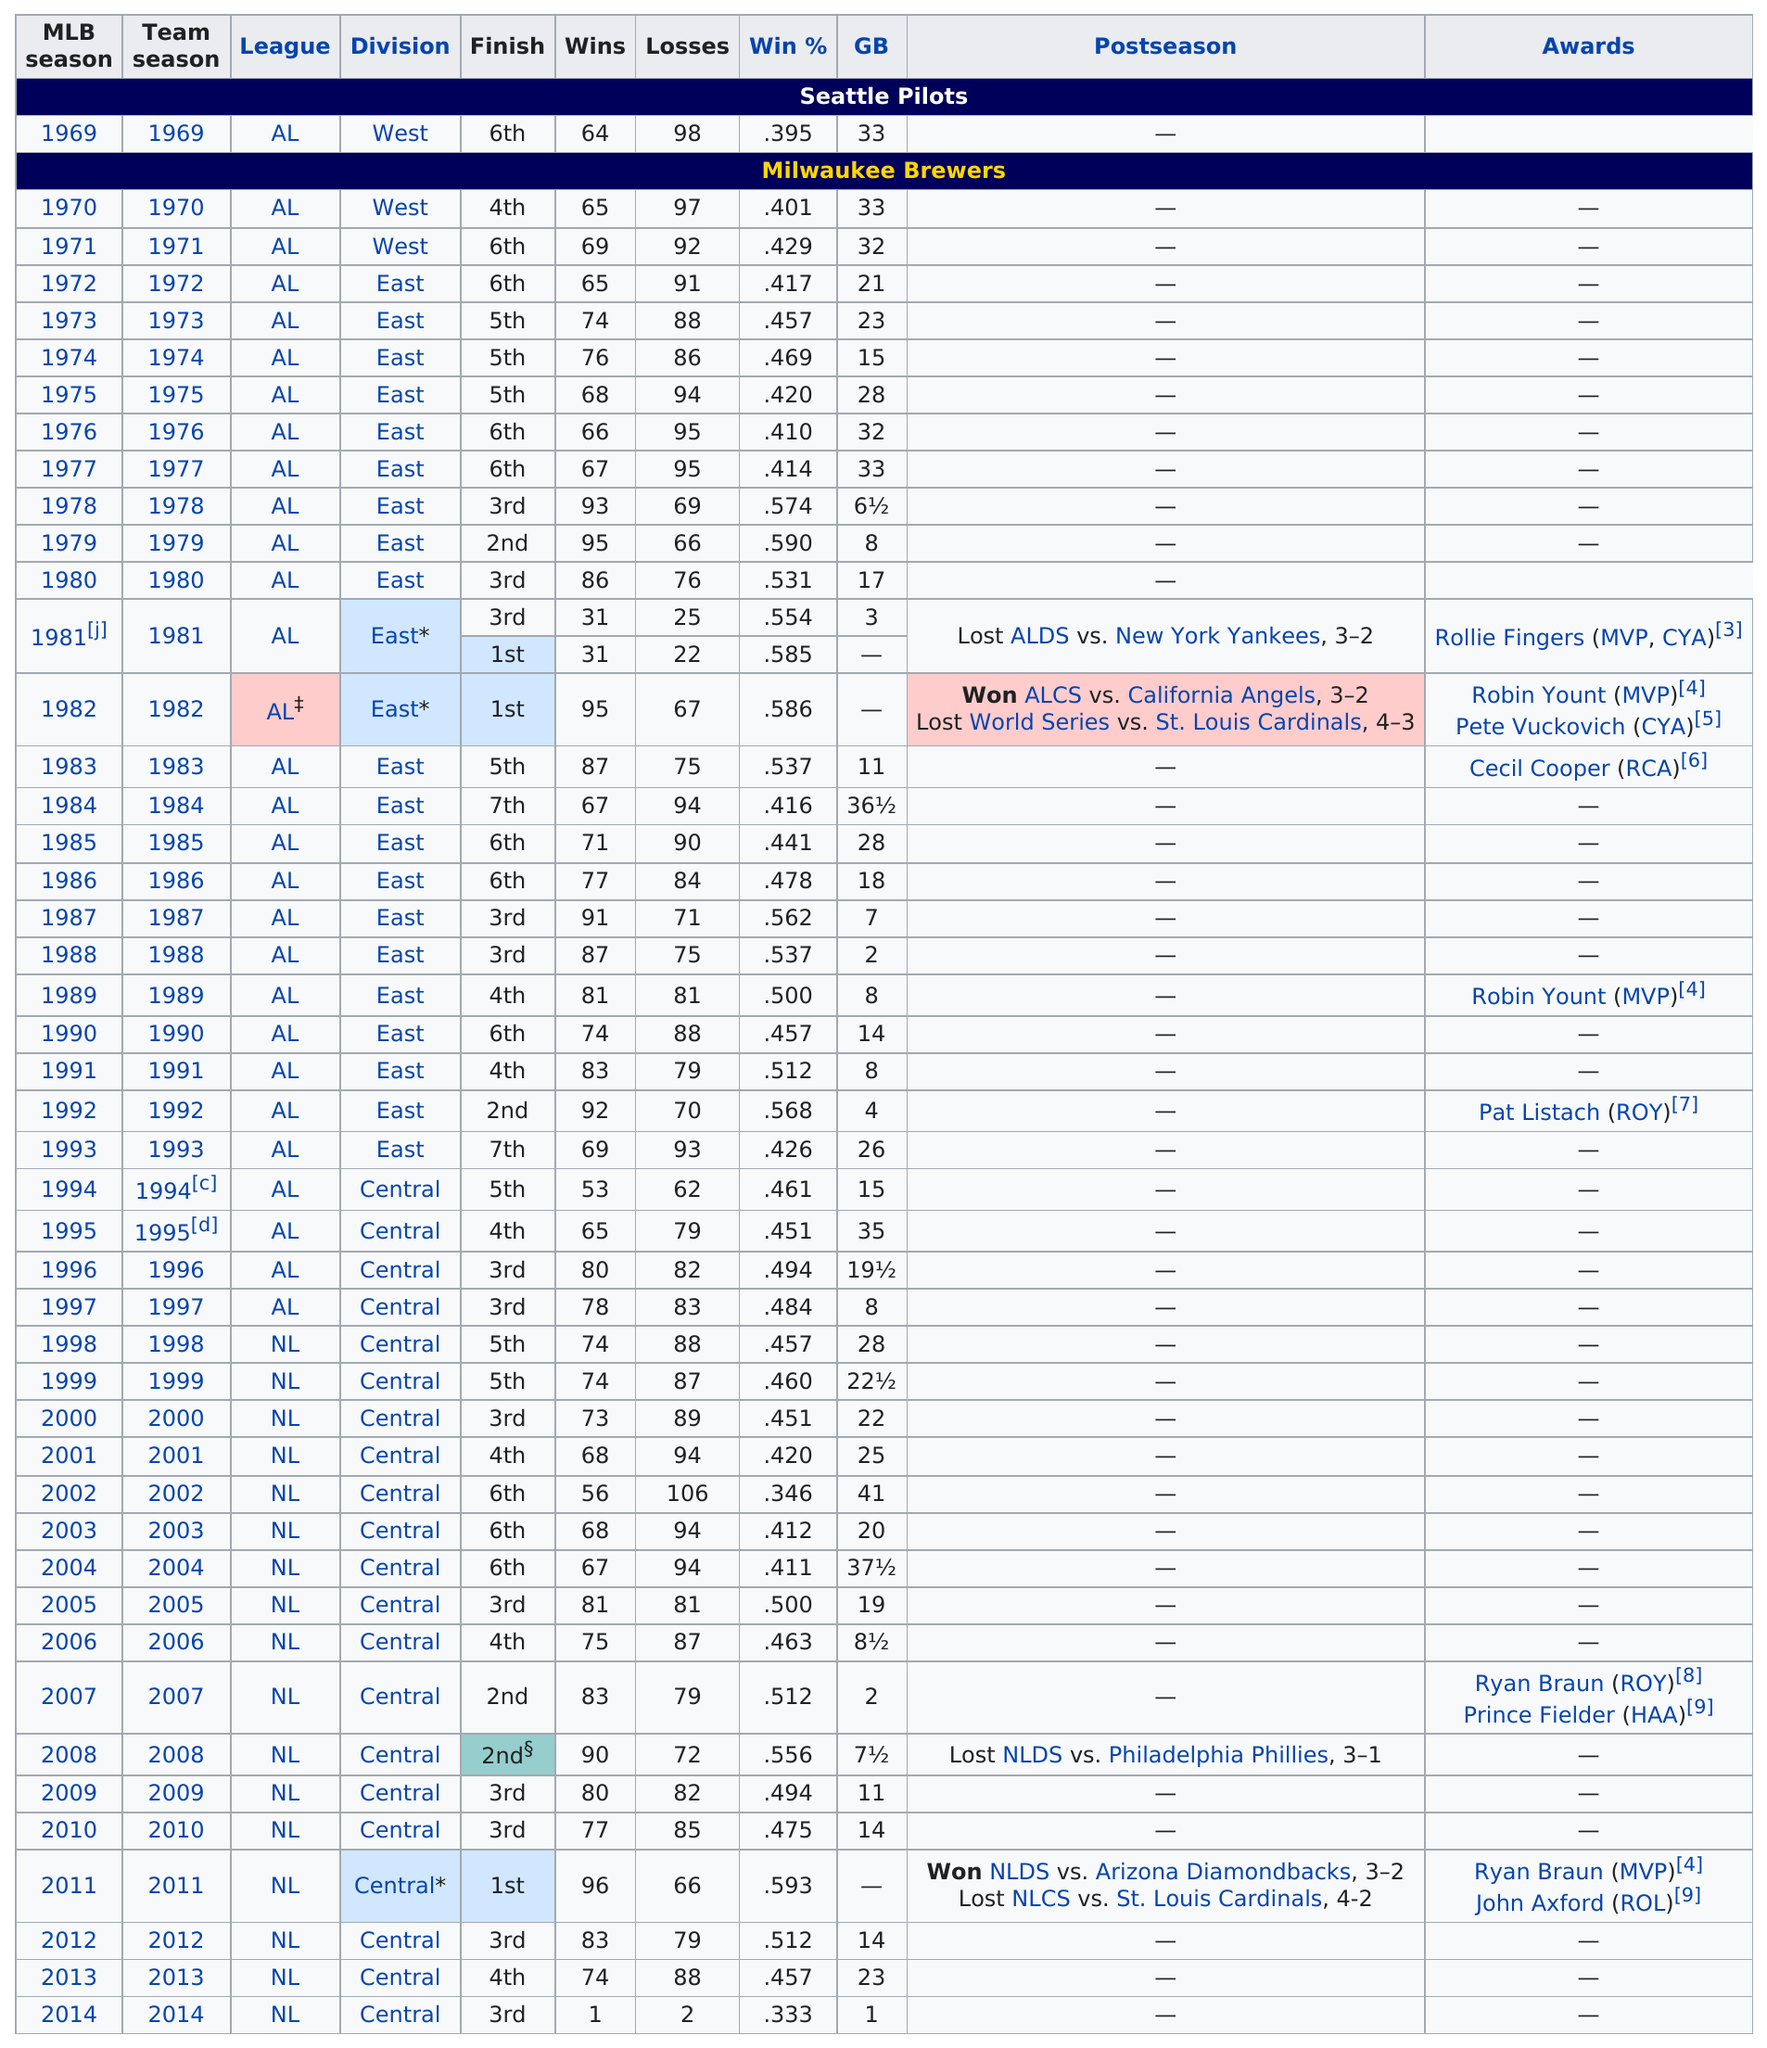List a handful of essential elements in this visual. The Milwaukee Brewers have been competing in the National League for 17 consecutive years. The winning percentage in 1994 was not the same as in 1999, as the latter was lower. The Milwaukee Brewers went eleven consecutive seasons without qualifying for the playoffs. In the period between 1984 and 1988, a total of 414 losses were recorded. The wins in 1970 are the same as the wins in 1972. Yes. 